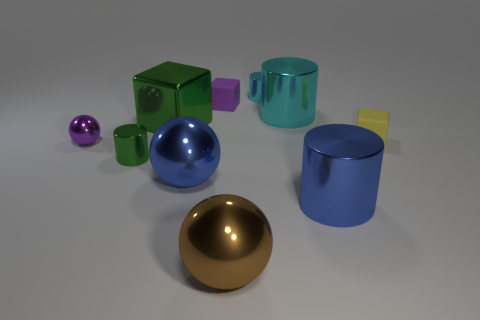Subtract all small yellow matte cubes. How many cubes are left? 2 Subtract all green blocks. How many cyan cylinders are left? 2 Subtract 1 spheres. How many spheres are left? 2 Subtract all blue cylinders. How many cylinders are left? 3 Subtract all brown cylinders. Subtract all gray spheres. How many cylinders are left? 4 Subtract all balls. How many objects are left? 7 Add 7 blue objects. How many blue objects are left? 9 Add 7 tiny spheres. How many tiny spheres exist? 8 Subtract 1 blue cylinders. How many objects are left? 9 Subtract all cyan cylinders. Subtract all brown objects. How many objects are left? 7 